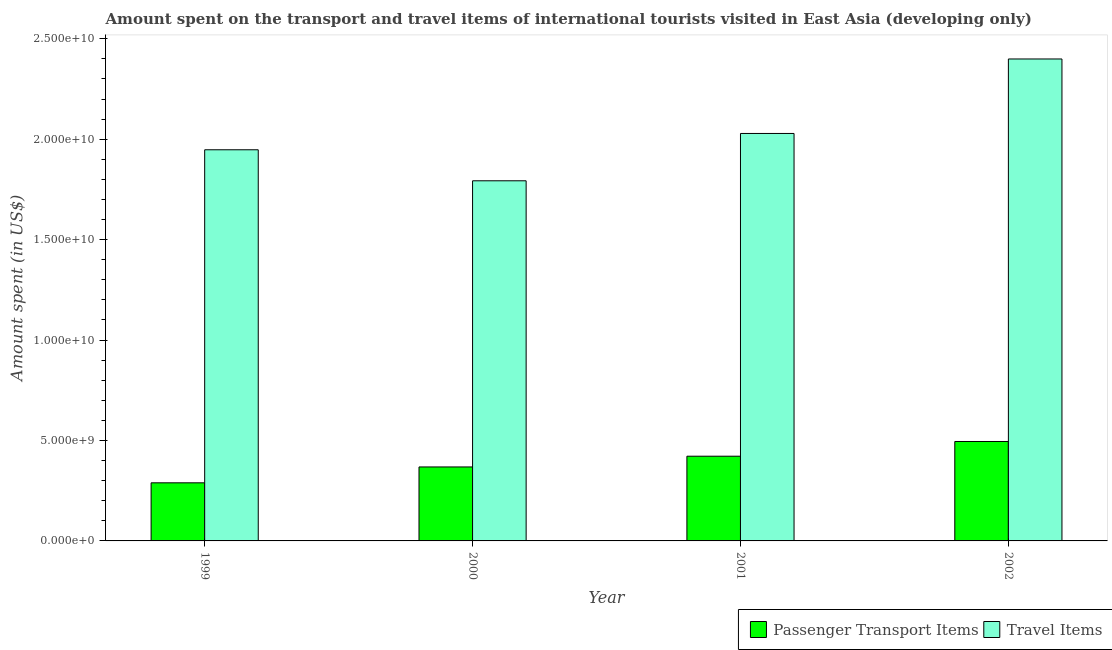Are the number of bars per tick equal to the number of legend labels?
Your answer should be compact. Yes. Are the number of bars on each tick of the X-axis equal?
Your response must be concise. Yes. How many bars are there on the 1st tick from the left?
Make the answer very short. 2. What is the amount spent in travel items in 2002?
Keep it short and to the point. 2.40e+1. Across all years, what is the maximum amount spent in travel items?
Provide a succinct answer. 2.40e+1. Across all years, what is the minimum amount spent on passenger transport items?
Provide a succinct answer. 2.89e+09. In which year was the amount spent in travel items maximum?
Provide a succinct answer. 2002. In which year was the amount spent on passenger transport items minimum?
Your answer should be compact. 1999. What is the total amount spent in travel items in the graph?
Offer a very short reply. 8.17e+1. What is the difference between the amount spent on passenger transport items in 2000 and that in 2001?
Ensure brevity in your answer.  -5.35e+08. What is the difference between the amount spent in travel items in 2000 and the amount spent on passenger transport items in 1999?
Provide a short and direct response. -1.54e+09. What is the average amount spent in travel items per year?
Give a very brief answer. 2.04e+1. In the year 2000, what is the difference between the amount spent on passenger transport items and amount spent in travel items?
Offer a terse response. 0. What is the ratio of the amount spent in travel items in 2000 to that in 2001?
Your response must be concise. 0.88. Is the difference between the amount spent in travel items in 1999 and 2000 greater than the difference between the amount spent on passenger transport items in 1999 and 2000?
Provide a short and direct response. No. What is the difference between the highest and the second highest amount spent on passenger transport items?
Give a very brief answer. 7.33e+08. What is the difference between the highest and the lowest amount spent in travel items?
Your response must be concise. 6.07e+09. In how many years, is the amount spent in travel items greater than the average amount spent in travel items taken over all years?
Your answer should be very brief. 1. What does the 2nd bar from the left in 2001 represents?
Give a very brief answer. Travel Items. What does the 2nd bar from the right in 2002 represents?
Provide a short and direct response. Passenger Transport Items. How many bars are there?
Provide a short and direct response. 8. Are all the bars in the graph horizontal?
Provide a succinct answer. No. How many years are there in the graph?
Provide a short and direct response. 4. What is the difference between two consecutive major ticks on the Y-axis?
Ensure brevity in your answer.  5.00e+09. Are the values on the major ticks of Y-axis written in scientific E-notation?
Offer a terse response. Yes. Does the graph contain any zero values?
Provide a succinct answer. No. Does the graph contain grids?
Offer a very short reply. No. What is the title of the graph?
Your answer should be very brief. Amount spent on the transport and travel items of international tourists visited in East Asia (developing only). What is the label or title of the X-axis?
Your response must be concise. Year. What is the label or title of the Y-axis?
Your response must be concise. Amount spent (in US$). What is the Amount spent (in US$) of Passenger Transport Items in 1999?
Ensure brevity in your answer.  2.89e+09. What is the Amount spent (in US$) in Travel Items in 1999?
Provide a succinct answer. 1.95e+1. What is the Amount spent (in US$) of Passenger Transport Items in 2000?
Give a very brief answer. 3.68e+09. What is the Amount spent (in US$) of Travel Items in 2000?
Ensure brevity in your answer.  1.79e+1. What is the Amount spent (in US$) of Passenger Transport Items in 2001?
Your response must be concise. 4.22e+09. What is the Amount spent (in US$) in Travel Items in 2001?
Your answer should be very brief. 2.03e+1. What is the Amount spent (in US$) of Passenger Transport Items in 2002?
Your response must be concise. 4.95e+09. What is the Amount spent (in US$) in Travel Items in 2002?
Give a very brief answer. 2.40e+1. Across all years, what is the maximum Amount spent (in US$) of Passenger Transport Items?
Provide a succinct answer. 4.95e+09. Across all years, what is the maximum Amount spent (in US$) in Travel Items?
Your answer should be compact. 2.40e+1. Across all years, what is the minimum Amount spent (in US$) in Passenger Transport Items?
Your response must be concise. 2.89e+09. Across all years, what is the minimum Amount spent (in US$) of Travel Items?
Keep it short and to the point. 1.79e+1. What is the total Amount spent (in US$) of Passenger Transport Items in the graph?
Ensure brevity in your answer.  1.57e+1. What is the total Amount spent (in US$) of Travel Items in the graph?
Give a very brief answer. 8.17e+1. What is the difference between the Amount spent (in US$) in Passenger Transport Items in 1999 and that in 2000?
Give a very brief answer. -7.90e+08. What is the difference between the Amount spent (in US$) of Travel Items in 1999 and that in 2000?
Give a very brief answer. 1.54e+09. What is the difference between the Amount spent (in US$) in Passenger Transport Items in 1999 and that in 2001?
Your answer should be compact. -1.33e+09. What is the difference between the Amount spent (in US$) of Travel Items in 1999 and that in 2001?
Keep it short and to the point. -8.12e+08. What is the difference between the Amount spent (in US$) of Passenger Transport Items in 1999 and that in 2002?
Ensure brevity in your answer.  -2.06e+09. What is the difference between the Amount spent (in US$) of Travel Items in 1999 and that in 2002?
Your answer should be very brief. -4.52e+09. What is the difference between the Amount spent (in US$) of Passenger Transport Items in 2000 and that in 2001?
Your answer should be compact. -5.35e+08. What is the difference between the Amount spent (in US$) in Travel Items in 2000 and that in 2001?
Offer a terse response. -2.36e+09. What is the difference between the Amount spent (in US$) in Passenger Transport Items in 2000 and that in 2002?
Give a very brief answer. -1.27e+09. What is the difference between the Amount spent (in US$) in Travel Items in 2000 and that in 2002?
Your response must be concise. -6.07e+09. What is the difference between the Amount spent (in US$) in Passenger Transport Items in 2001 and that in 2002?
Provide a succinct answer. -7.33e+08. What is the difference between the Amount spent (in US$) of Travel Items in 2001 and that in 2002?
Provide a succinct answer. -3.71e+09. What is the difference between the Amount spent (in US$) of Passenger Transport Items in 1999 and the Amount spent (in US$) of Travel Items in 2000?
Offer a terse response. -1.50e+1. What is the difference between the Amount spent (in US$) in Passenger Transport Items in 1999 and the Amount spent (in US$) in Travel Items in 2001?
Ensure brevity in your answer.  -1.74e+1. What is the difference between the Amount spent (in US$) in Passenger Transport Items in 1999 and the Amount spent (in US$) in Travel Items in 2002?
Offer a terse response. -2.11e+1. What is the difference between the Amount spent (in US$) in Passenger Transport Items in 2000 and the Amount spent (in US$) in Travel Items in 2001?
Give a very brief answer. -1.66e+1. What is the difference between the Amount spent (in US$) of Passenger Transport Items in 2000 and the Amount spent (in US$) of Travel Items in 2002?
Give a very brief answer. -2.03e+1. What is the difference between the Amount spent (in US$) in Passenger Transport Items in 2001 and the Amount spent (in US$) in Travel Items in 2002?
Your answer should be compact. -1.98e+1. What is the average Amount spent (in US$) of Passenger Transport Items per year?
Provide a succinct answer. 3.94e+09. What is the average Amount spent (in US$) in Travel Items per year?
Offer a terse response. 2.04e+1. In the year 1999, what is the difference between the Amount spent (in US$) of Passenger Transport Items and Amount spent (in US$) of Travel Items?
Provide a succinct answer. -1.66e+1. In the year 2000, what is the difference between the Amount spent (in US$) in Passenger Transport Items and Amount spent (in US$) in Travel Items?
Offer a very short reply. -1.42e+1. In the year 2001, what is the difference between the Amount spent (in US$) of Passenger Transport Items and Amount spent (in US$) of Travel Items?
Your answer should be very brief. -1.61e+1. In the year 2002, what is the difference between the Amount spent (in US$) in Passenger Transport Items and Amount spent (in US$) in Travel Items?
Provide a short and direct response. -1.90e+1. What is the ratio of the Amount spent (in US$) in Passenger Transport Items in 1999 to that in 2000?
Your answer should be very brief. 0.79. What is the ratio of the Amount spent (in US$) of Travel Items in 1999 to that in 2000?
Your response must be concise. 1.09. What is the ratio of the Amount spent (in US$) of Passenger Transport Items in 1999 to that in 2001?
Your answer should be compact. 0.69. What is the ratio of the Amount spent (in US$) in Passenger Transport Items in 1999 to that in 2002?
Ensure brevity in your answer.  0.58. What is the ratio of the Amount spent (in US$) in Travel Items in 1999 to that in 2002?
Your answer should be compact. 0.81. What is the ratio of the Amount spent (in US$) in Passenger Transport Items in 2000 to that in 2001?
Provide a succinct answer. 0.87. What is the ratio of the Amount spent (in US$) of Travel Items in 2000 to that in 2001?
Your answer should be compact. 0.88. What is the ratio of the Amount spent (in US$) of Passenger Transport Items in 2000 to that in 2002?
Make the answer very short. 0.74. What is the ratio of the Amount spent (in US$) in Travel Items in 2000 to that in 2002?
Keep it short and to the point. 0.75. What is the ratio of the Amount spent (in US$) of Passenger Transport Items in 2001 to that in 2002?
Provide a short and direct response. 0.85. What is the ratio of the Amount spent (in US$) in Travel Items in 2001 to that in 2002?
Your answer should be compact. 0.85. What is the difference between the highest and the second highest Amount spent (in US$) of Passenger Transport Items?
Ensure brevity in your answer.  7.33e+08. What is the difference between the highest and the second highest Amount spent (in US$) of Travel Items?
Offer a very short reply. 3.71e+09. What is the difference between the highest and the lowest Amount spent (in US$) in Passenger Transport Items?
Make the answer very short. 2.06e+09. What is the difference between the highest and the lowest Amount spent (in US$) of Travel Items?
Your response must be concise. 6.07e+09. 